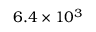<formula> <loc_0><loc_0><loc_500><loc_500>6 . 4 \times 1 0 ^ { 3 }</formula> 